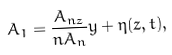Convert formula to latex. <formula><loc_0><loc_0><loc_500><loc_500>A _ { 1 } = \frac { A _ { n z } } { n A _ { n } } y + \eta ( z , t ) ,</formula> 